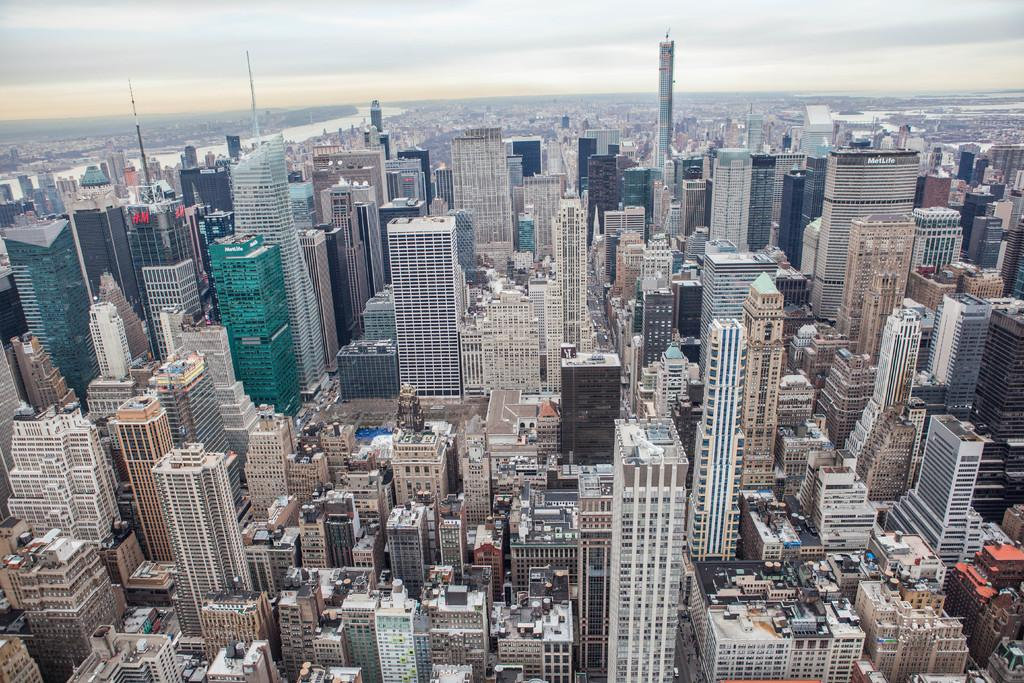What type of structures can be seen in the image? There are many buildings in the image. What natural element is visible in the image? There is water visible in the image. What can be seen in the background of the image? The sky is visible in the background of the image. What type of plant is being used for arithmetic in the image? There is no plant or arithmetic present in the image. What sign can be seen on the buildings in the image? There is no sign visible on the buildings in the image. 